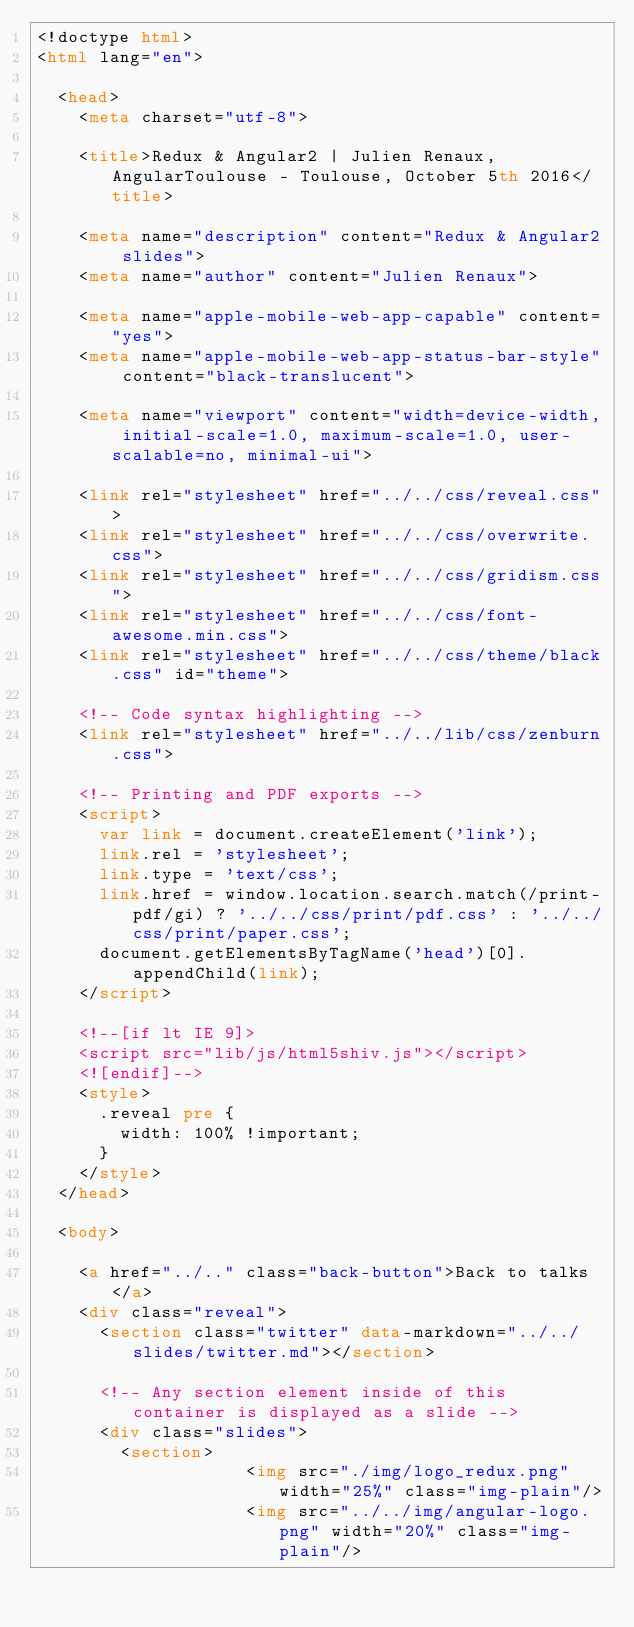<code> <loc_0><loc_0><loc_500><loc_500><_HTML_><!doctype html>
<html lang="en">

	<head>
		<meta charset="utf-8">

		<title>Redux & Angular2 | Julien Renaux, AngularToulouse - Toulouse, October 5th 2016</title>

		<meta name="description" content="Redux & Angular2 slides">
		<meta name="author" content="Julien Renaux">

		<meta name="apple-mobile-web-app-capable" content="yes">
		<meta name="apple-mobile-web-app-status-bar-style" content="black-translucent">

		<meta name="viewport" content="width=device-width, initial-scale=1.0, maximum-scale=1.0, user-scalable=no, minimal-ui">

		<link rel="stylesheet" href="../../css/reveal.css">
		<link rel="stylesheet" href="../../css/overwrite.css">
		<link rel="stylesheet" href="../../css/gridism.css">
		<link rel="stylesheet" href="../../css/font-awesome.min.css">
		<link rel="stylesheet" href="../../css/theme/black.css" id="theme">

		<!-- Code syntax highlighting -->
		<link rel="stylesheet" href="../../lib/css/zenburn.css">

		<!-- Printing and PDF exports -->
		<script>
			var link = document.createElement('link');
			link.rel = 'stylesheet';
			link.type = 'text/css';
			link.href = window.location.search.match(/print-pdf/gi) ? '../../css/print/pdf.css' : '../../css/print/paper.css';
			document.getElementsByTagName('head')[0].appendChild(link);
		</script>

		<!--[if lt IE 9]>
		<script src="lib/js/html5shiv.js"></script>
		<![endif]-->
		<style>
			.reveal pre {
				width: 100% !important;
			}
		</style>
	</head>

	<body>

		<a href="../.." class="back-button">Back to talks</a>
		<div class="reveal">
			<section class="twitter" data-markdown="../../slides/twitter.md"></section>

			<!-- Any section element inside of this container is displayed as a slide -->
			<div class="slides">
				<section>
                    <img src="./img/logo_redux.png" width="25%" class="img-plain"/>
                    <img src="../../img/angular-logo.png" width="20%" class="img-plain"/></code> 